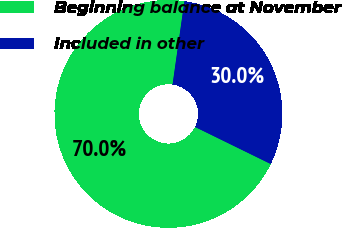<chart> <loc_0><loc_0><loc_500><loc_500><pie_chart><fcel>Beginning balance at November<fcel>Included in other<nl><fcel>70.0%<fcel>30.0%<nl></chart> 